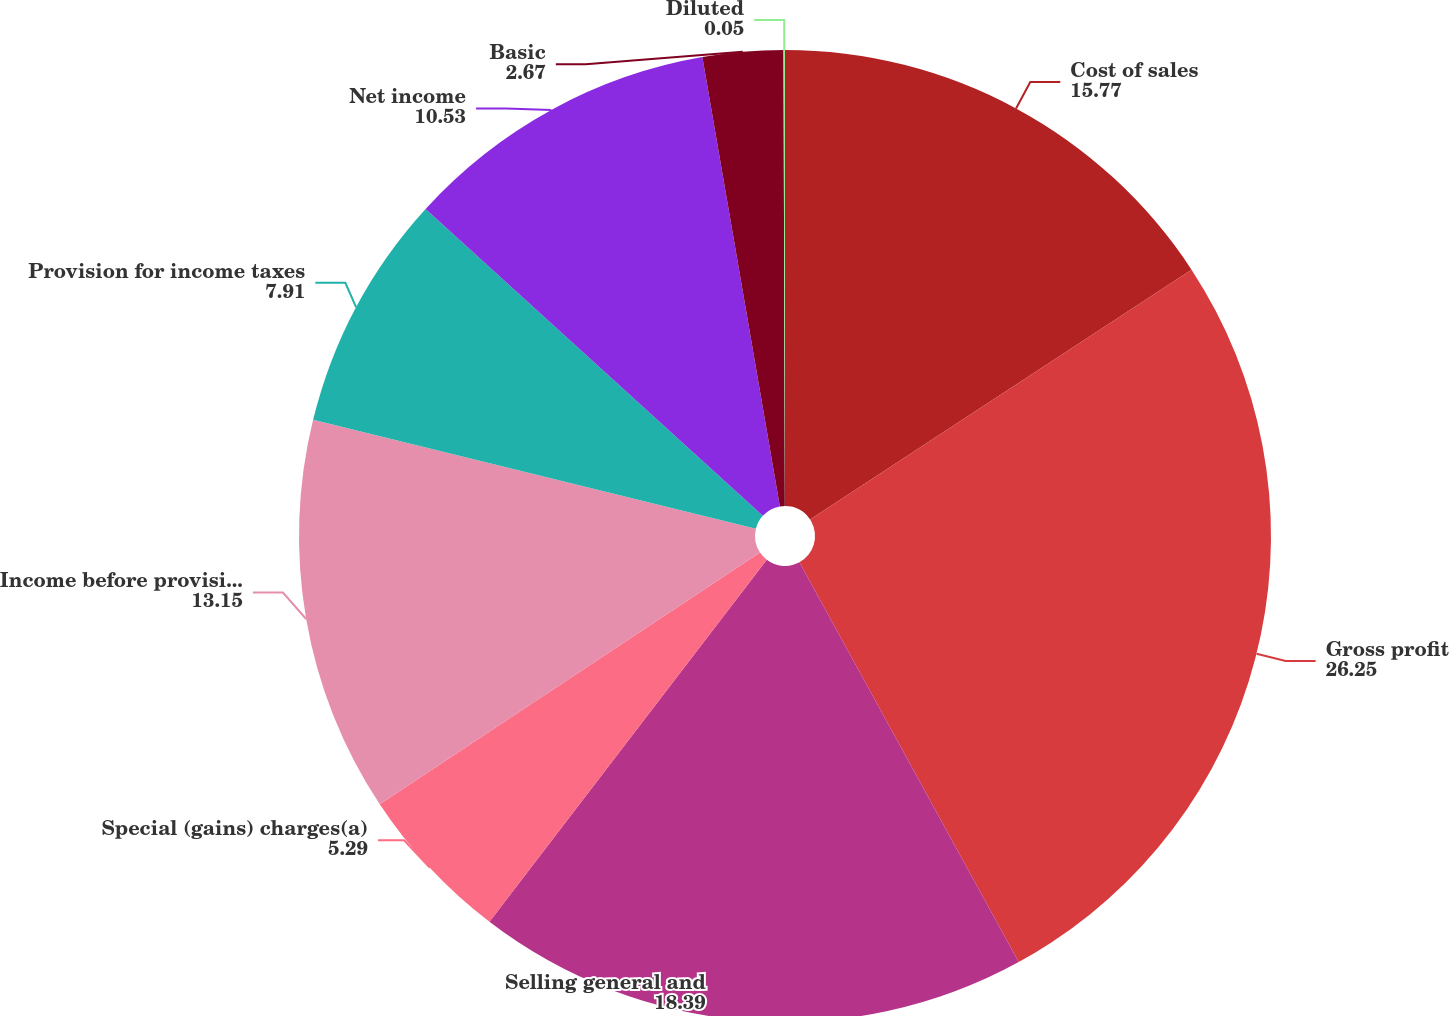<chart> <loc_0><loc_0><loc_500><loc_500><pie_chart><fcel>Cost of sales<fcel>Gross profit<fcel>Selling general and<fcel>Special (gains) charges(a)<fcel>Income before provision for<fcel>Provision for income taxes<fcel>Net income<fcel>Basic<fcel>Diluted<nl><fcel>15.77%<fcel>26.25%<fcel>18.39%<fcel>5.29%<fcel>13.15%<fcel>7.91%<fcel>10.53%<fcel>2.67%<fcel>0.05%<nl></chart> 